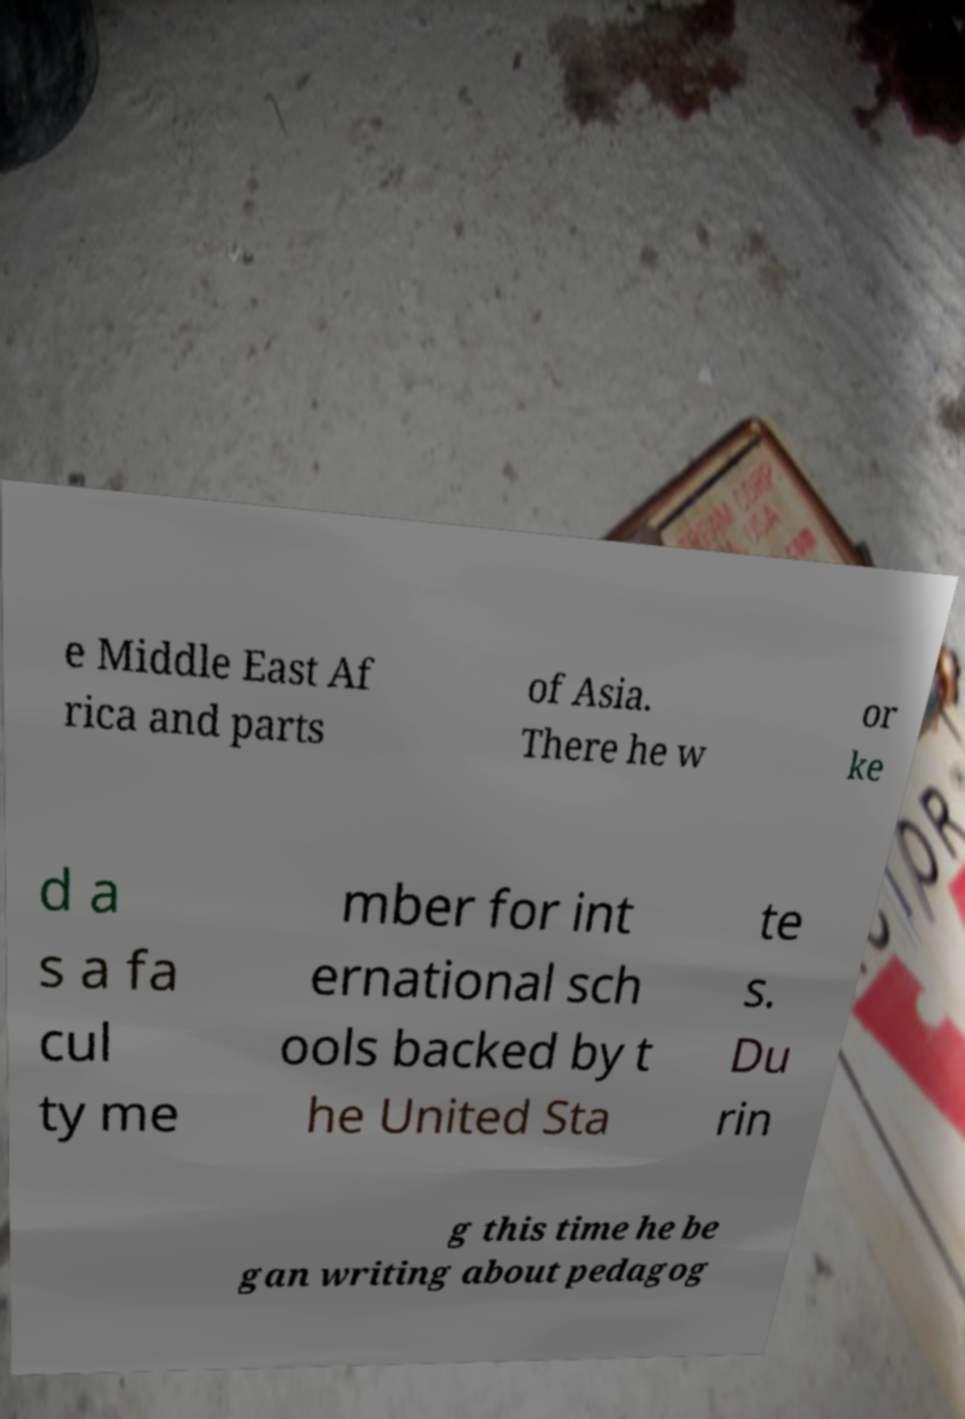Can you accurately transcribe the text from the provided image for me? e Middle East Af rica and parts of Asia. There he w or ke d a s a fa cul ty me mber for int ernational sch ools backed by t he United Sta te s. Du rin g this time he be gan writing about pedagog 